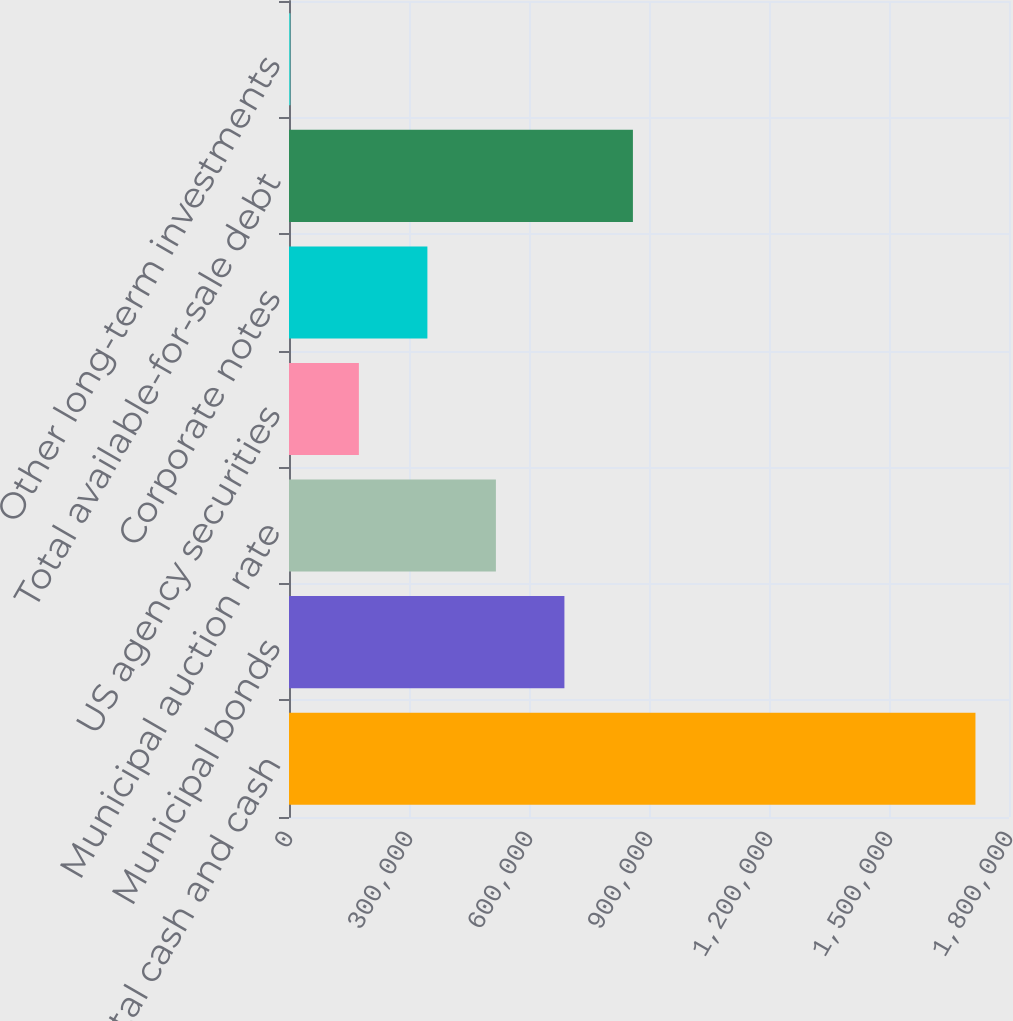Convert chart to OTSL. <chart><loc_0><loc_0><loc_500><loc_500><bar_chart><fcel>Total cash and cash<fcel>Municipal bonds<fcel>Municipal auction rate<fcel>US agency securities<fcel>Corporate notes<fcel>Total available-for-sale debt<fcel>Other long-term investments<nl><fcel>1.71614e+06<fcel>688524<fcel>517254<fcel>174715<fcel>345985<fcel>859794<fcel>3445<nl></chart> 